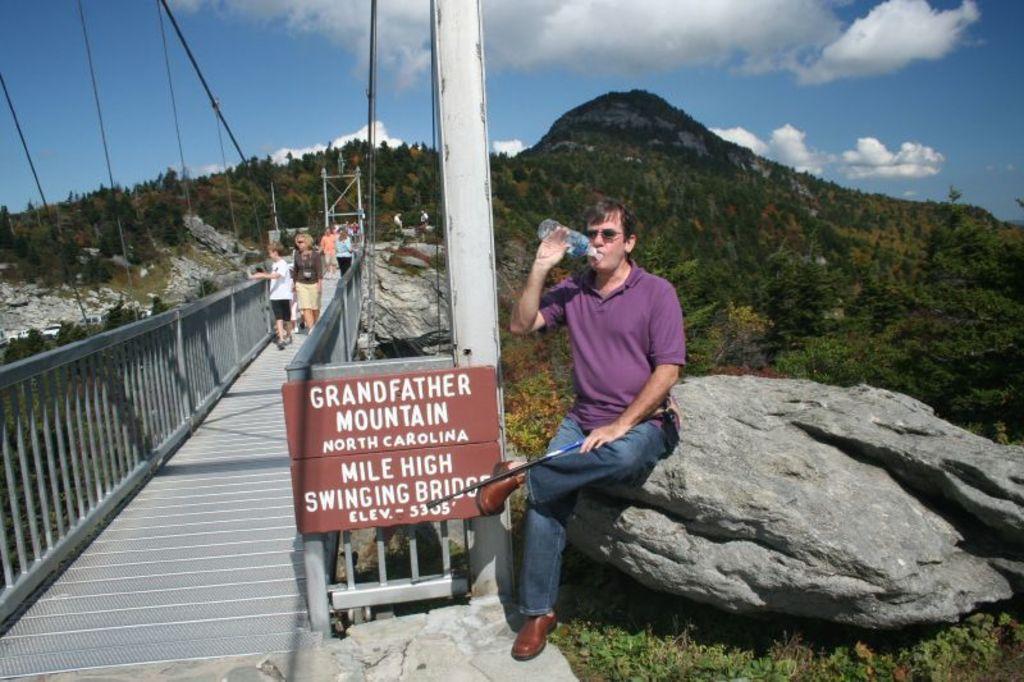In one or two sentences, can you explain what this image depicts? In this image there is a person sitting on the rock and drinking water and holding a stick. In the left there is a bridge with a text board and on the bridge there are few people walking. In the background there is a mountain with full of trees. At the top there is a cloudy sky. 